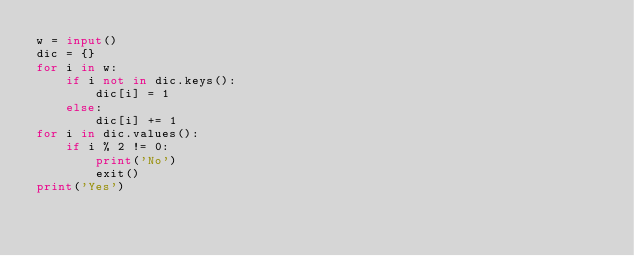<code> <loc_0><loc_0><loc_500><loc_500><_Python_>w = input()
dic = {}
for i in w:
    if i not in dic.keys():
        dic[i] = 1
    else:
        dic[i] += 1
for i in dic.values():
    if i % 2 != 0:
        print('No')
        exit()
print('Yes')</code> 